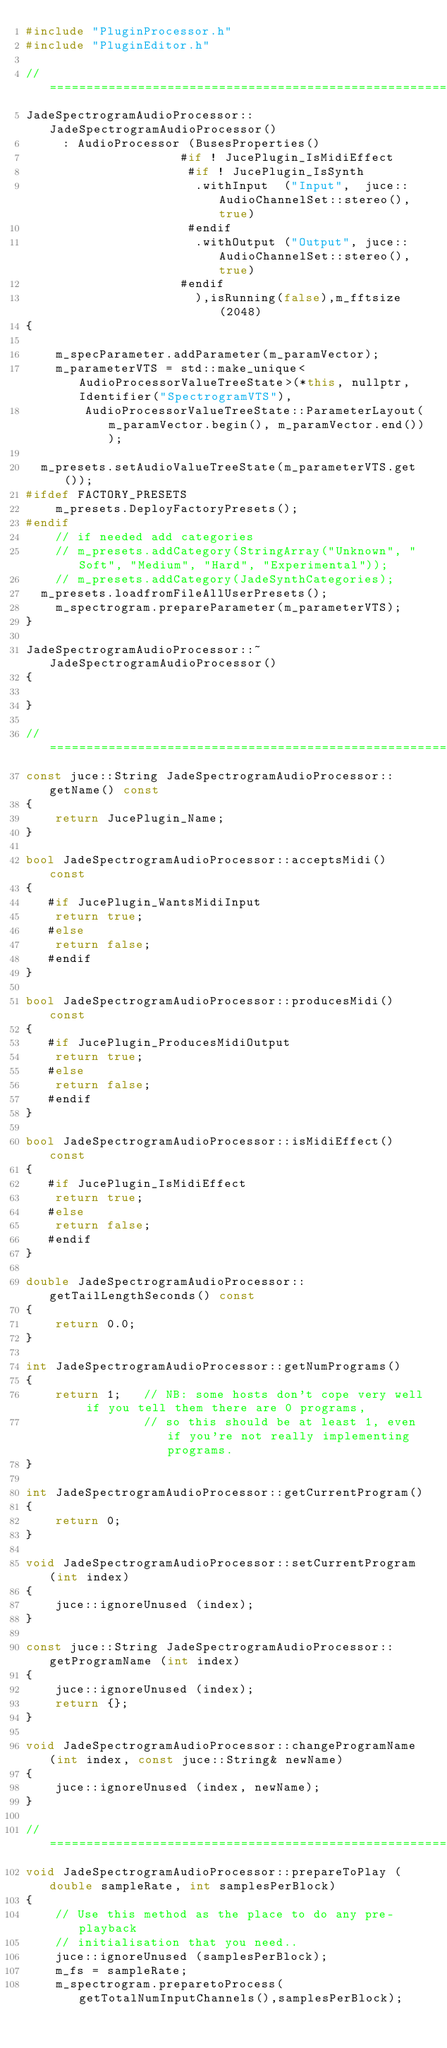Convert code to text. <code><loc_0><loc_0><loc_500><loc_500><_C++_>#include "PluginProcessor.h"
#include "PluginEditor.h"

//==============================================================================
JadeSpectrogramAudioProcessor::JadeSpectrogramAudioProcessor()
     : AudioProcessor (BusesProperties()
                     #if ! JucePlugin_IsMidiEffect
                      #if ! JucePlugin_IsSynth
                       .withInput  ("Input",  juce::AudioChannelSet::stereo(), true)
                      #endif
                       .withOutput ("Output", juce::AudioChannelSet::stereo(), true)
                     #endif
                       ),isRunning(false),m_fftsize(2048)
{

    m_specParameter.addParameter(m_paramVector);
    m_parameterVTS = std::make_unique<AudioProcessorValueTreeState>(*this, nullptr, Identifier("SpectrogramVTS"),
        AudioProcessorValueTreeState::ParameterLayout(m_paramVector.begin(), m_paramVector.end()));

	m_presets.setAudioValueTreeState(m_parameterVTS.get());
#ifdef FACTORY_PRESETS    
    m_presets.DeployFactoryPresets();
#endif
    // if needed add categories
    // m_presets.addCategory(StringArray("Unknown", "Soft", "Medium", "Hard", "Experimental"));
    // m_presets.addCategory(JadeSynthCategories);
	m_presets.loadfromFileAllUserPresets();    
    m_spectrogram.prepareParameter(m_parameterVTS);
}

JadeSpectrogramAudioProcessor::~JadeSpectrogramAudioProcessor()
{

}

//==============================================================================
const juce::String JadeSpectrogramAudioProcessor::getName() const
{
    return JucePlugin_Name;
}

bool JadeSpectrogramAudioProcessor::acceptsMidi() const
{
   #if JucePlugin_WantsMidiInput
    return true;
   #else
    return false;
   #endif
}

bool JadeSpectrogramAudioProcessor::producesMidi() const
{
   #if JucePlugin_ProducesMidiOutput
    return true;
   #else
    return false;
   #endif
}

bool JadeSpectrogramAudioProcessor::isMidiEffect() const
{
   #if JucePlugin_IsMidiEffect
    return true;
   #else
    return false;
   #endif
}

double JadeSpectrogramAudioProcessor::getTailLengthSeconds() const
{
    return 0.0;
}

int JadeSpectrogramAudioProcessor::getNumPrograms()
{
    return 1;   // NB: some hosts don't cope very well if you tell them there are 0 programs,
                // so this should be at least 1, even if you're not really implementing programs.
}

int JadeSpectrogramAudioProcessor::getCurrentProgram()
{
    return 0;
}

void JadeSpectrogramAudioProcessor::setCurrentProgram (int index)
{
    juce::ignoreUnused (index);
}

const juce::String JadeSpectrogramAudioProcessor::getProgramName (int index)
{
    juce::ignoreUnused (index);
    return {};
}

void JadeSpectrogramAudioProcessor::changeProgramName (int index, const juce::String& newName)
{
    juce::ignoreUnused (index, newName);
}

//==============================================================================
void JadeSpectrogramAudioProcessor::prepareToPlay (double sampleRate, int samplesPerBlock)
{
    // Use this method as the place to do any pre-playback
    // initialisation that you need..
    juce::ignoreUnused (samplesPerBlock);
    m_fs = sampleRate;
    m_spectrogram.preparetoProcess(getTotalNumInputChannels(),samplesPerBlock);</code> 